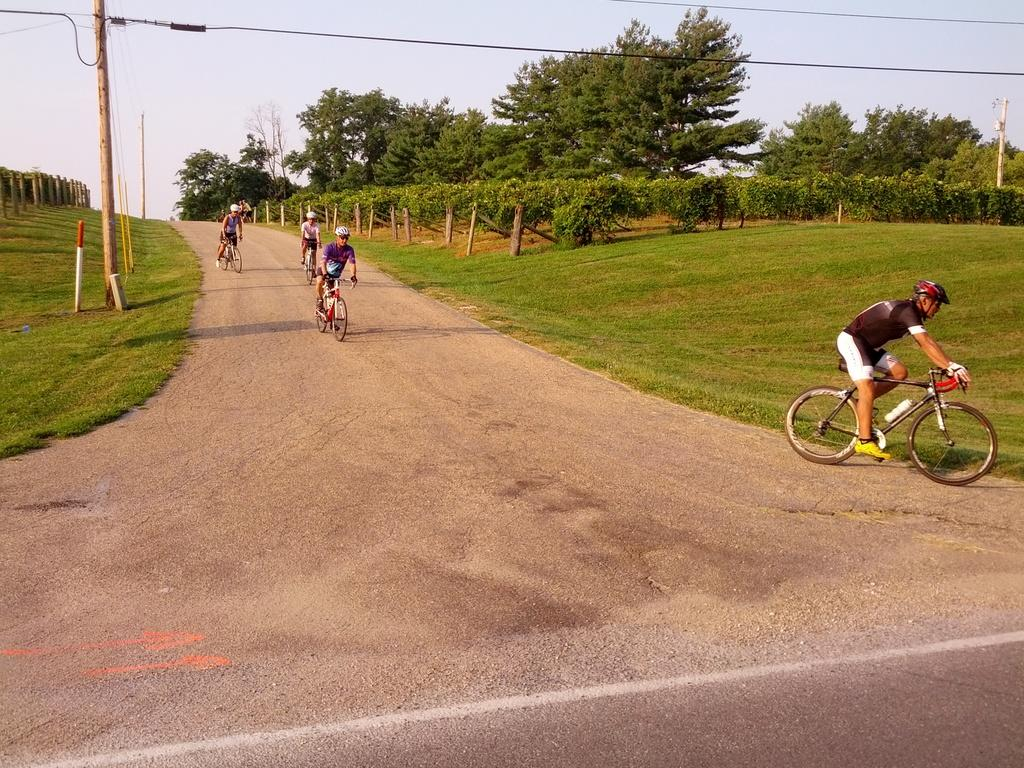What are the people in the image using for transportation? There are persons on bicycles in the image. What type of setting is depicted in the image? The image depicts a road. What type of vegetation can be seen in the image? There are plants, grass, and trees in the image. What is visible in the sky in the image? The sky is visible in the image. What object can be seen in the image that is not related to transportation or vegetation? There is a pole in the image. Can you see a snail crawling on the grass in the image? There is no snail visible in the image; it only features persons on bicycles, a road, plants, grass, trees, the sky, and a pole. What type of fan is being used by the persons on bicycles in the image? There is no fan present in the image; the persons on bicycles are not using any fans for transportation or cooling. 